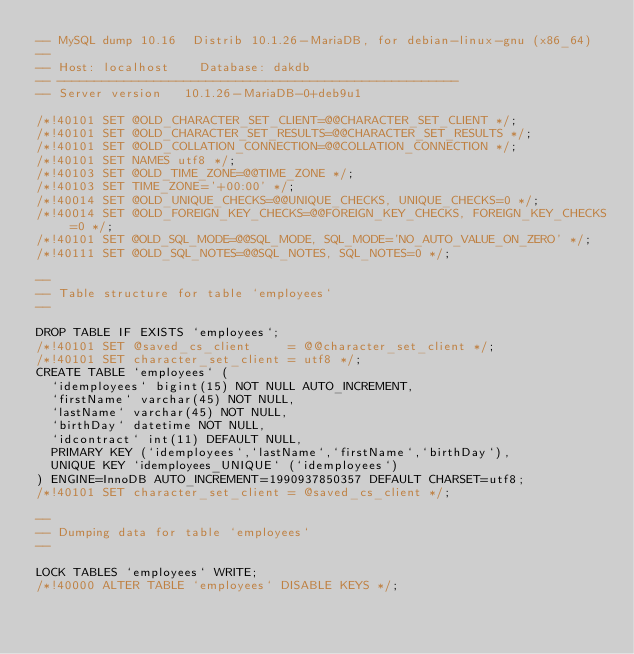Convert code to text. <code><loc_0><loc_0><loc_500><loc_500><_SQL_>-- MySQL dump 10.16  Distrib 10.1.26-MariaDB, for debian-linux-gnu (x86_64)
--
-- Host: localhost    Database: dakdb
-- ------------------------------------------------------
-- Server version	10.1.26-MariaDB-0+deb9u1

/*!40101 SET @OLD_CHARACTER_SET_CLIENT=@@CHARACTER_SET_CLIENT */;
/*!40101 SET @OLD_CHARACTER_SET_RESULTS=@@CHARACTER_SET_RESULTS */;
/*!40101 SET @OLD_COLLATION_CONNECTION=@@COLLATION_CONNECTION */;
/*!40101 SET NAMES utf8 */;
/*!40103 SET @OLD_TIME_ZONE=@@TIME_ZONE */;
/*!40103 SET TIME_ZONE='+00:00' */;
/*!40014 SET @OLD_UNIQUE_CHECKS=@@UNIQUE_CHECKS, UNIQUE_CHECKS=0 */;
/*!40014 SET @OLD_FOREIGN_KEY_CHECKS=@@FOREIGN_KEY_CHECKS, FOREIGN_KEY_CHECKS=0 */;
/*!40101 SET @OLD_SQL_MODE=@@SQL_MODE, SQL_MODE='NO_AUTO_VALUE_ON_ZERO' */;
/*!40111 SET @OLD_SQL_NOTES=@@SQL_NOTES, SQL_NOTES=0 */;

--
-- Table structure for table `employees`
--

DROP TABLE IF EXISTS `employees`;
/*!40101 SET @saved_cs_client     = @@character_set_client */;
/*!40101 SET character_set_client = utf8 */;
CREATE TABLE `employees` (
  `idemployees` bigint(15) NOT NULL AUTO_INCREMENT,
  `firstName` varchar(45) NOT NULL,
  `lastName` varchar(45) NOT NULL,
  `birthDay` datetime NOT NULL,
  `idcontract` int(11) DEFAULT NULL,
  PRIMARY KEY (`idemployees`,`lastName`,`firstName`,`birthDay`),
  UNIQUE KEY `idemployees_UNIQUE` (`idemployees`)
) ENGINE=InnoDB AUTO_INCREMENT=1990937850357 DEFAULT CHARSET=utf8;
/*!40101 SET character_set_client = @saved_cs_client */;

--
-- Dumping data for table `employees`
--

LOCK TABLES `employees` WRITE;
/*!40000 ALTER TABLE `employees` DISABLE KEYS */;</code> 